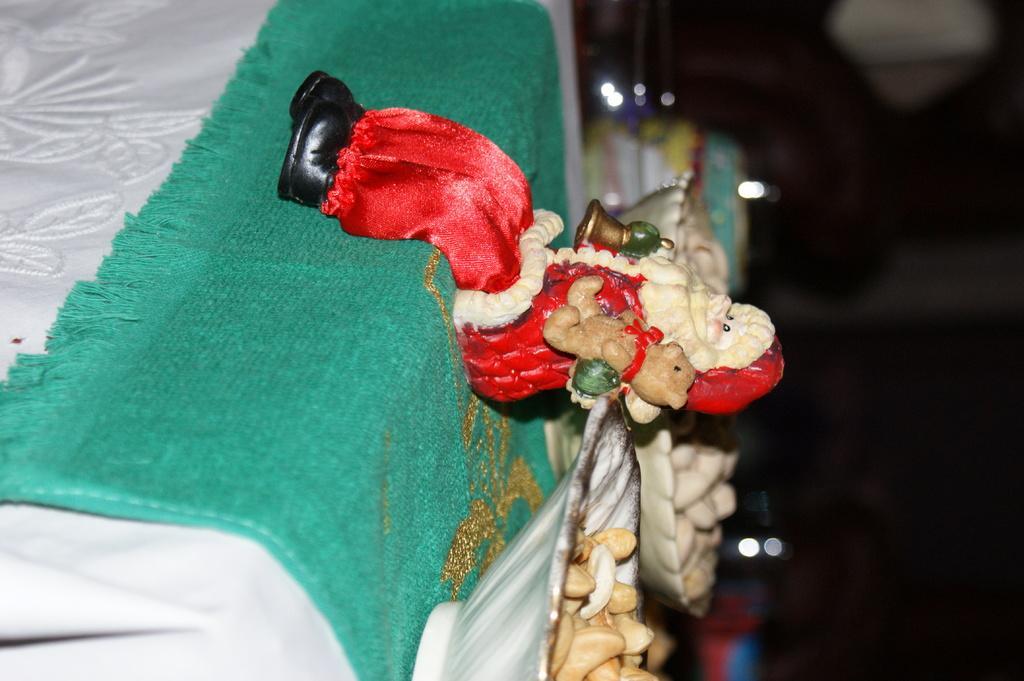In one or two sentences, can you explain what this image depicts? In this picture we can see a toy and there are food items in the bowels and the bowls are on the cloth. Behind the bowls, there's a dark background. 